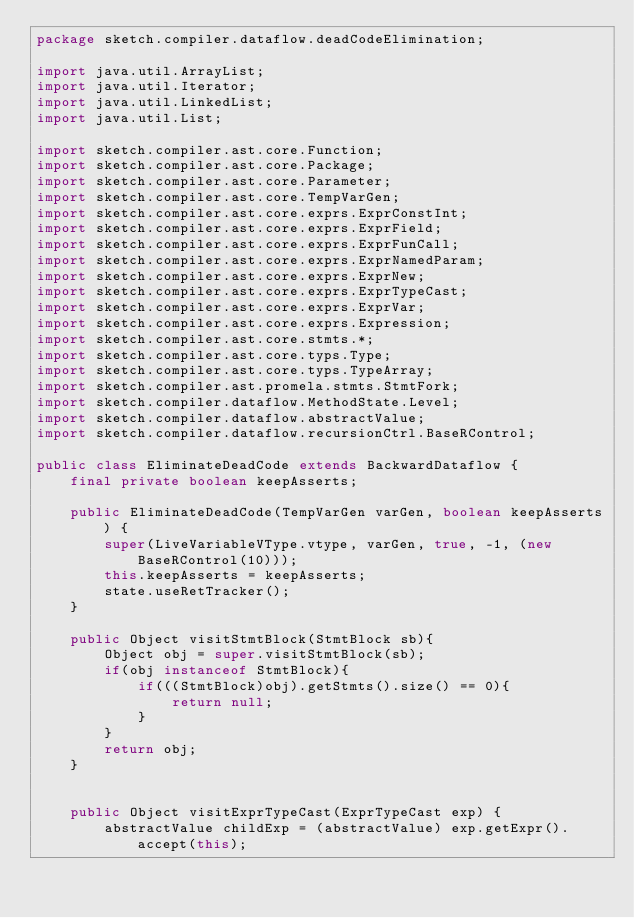<code> <loc_0><loc_0><loc_500><loc_500><_Java_>package sketch.compiler.dataflow.deadCodeElimination;

import java.util.ArrayList;
import java.util.Iterator;
import java.util.LinkedList;
import java.util.List;

import sketch.compiler.ast.core.Function;
import sketch.compiler.ast.core.Package;
import sketch.compiler.ast.core.Parameter;
import sketch.compiler.ast.core.TempVarGen;
import sketch.compiler.ast.core.exprs.ExprConstInt;
import sketch.compiler.ast.core.exprs.ExprField;
import sketch.compiler.ast.core.exprs.ExprFunCall;
import sketch.compiler.ast.core.exprs.ExprNamedParam;
import sketch.compiler.ast.core.exprs.ExprNew;
import sketch.compiler.ast.core.exprs.ExprTypeCast;
import sketch.compiler.ast.core.exprs.ExprVar;
import sketch.compiler.ast.core.exprs.Expression;
import sketch.compiler.ast.core.stmts.*;
import sketch.compiler.ast.core.typs.Type;
import sketch.compiler.ast.core.typs.TypeArray;
import sketch.compiler.ast.promela.stmts.StmtFork;
import sketch.compiler.dataflow.MethodState.Level;
import sketch.compiler.dataflow.abstractValue;
import sketch.compiler.dataflow.recursionCtrl.BaseRControl;

public class EliminateDeadCode extends BackwardDataflow {
	final private boolean keepAsserts;

    public EliminateDeadCode(TempVarGen varGen, boolean keepAsserts) {
        super(LiveVariableVType.vtype, varGen, true, -1, (new BaseRControl(10)));
		this.keepAsserts = keepAsserts;
        state.useRetTracker();
	}

	public Object visitStmtBlock(StmtBlock sb){
		Object obj = super.visitStmtBlock(sb);
		if(obj instanceof StmtBlock){
			if(((StmtBlock)obj).getStmts().size() == 0){
				return null;
			}
		}
		return obj;
	}


    public Object visitExprTypeCast(ExprTypeCast exp) {
        abstractValue childExp = (abstractValue) exp.getExpr().accept(this);</code> 